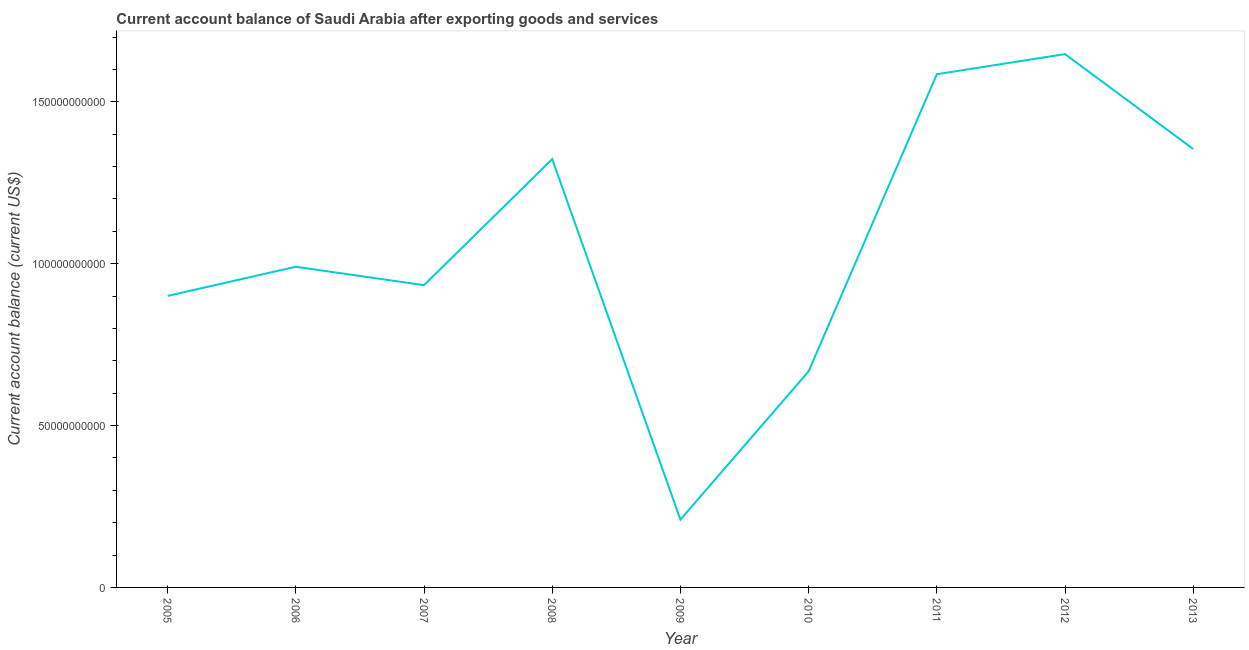What is the current account balance in 2006?
Your answer should be compact. 9.91e+1. Across all years, what is the maximum current account balance?
Offer a terse response. 1.65e+11. Across all years, what is the minimum current account balance?
Give a very brief answer. 2.10e+1. In which year was the current account balance maximum?
Keep it short and to the point. 2012. In which year was the current account balance minimum?
Keep it short and to the point. 2009. What is the sum of the current account balance?
Your answer should be compact. 9.61e+11. What is the difference between the current account balance in 2005 and 2010?
Your answer should be compact. 2.33e+1. What is the average current account balance per year?
Your response must be concise. 1.07e+11. What is the median current account balance?
Keep it short and to the point. 9.91e+1. Do a majority of the years between 2011 and 2012 (inclusive) have current account balance greater than 40000000000 US$?
Make the answer very short. Yes. What is the ratio of the current account balance in 2007 to that in 2011?
Ensure brevity in your answer.  0.59. Is the difference between the current account balance in 2007 and 2008 greater than the difference between any two years?
Offer a very short reply. No. What is the difference between the highest and the second highest current account balance?
Give a very brief answer. 6.22e+09. What is the difference between the highest and the lowest current account balance?
Offer a terse response. 1.44e+11. In how many years, is the current account balance greater than the average current account balance taken over all years?
Offer a very short reply. 4. Does the current account balance monotonically increase over the years?
Offer a terse response. No. Are the values on the major ticks of Y-axis written in scientific E-notation?
Keep it short and to the point. No. Does the graph contain any zero values?
Offer a terse response. No. What is the title of the graph?
Provide a short and direct response. Current account balance of Saudi Arabia after exporting goods and services. What is the label or title of the Y-axis?
Ensure brevity in your answer.  Current account balance (current US$). What is the Current account balance (current US$) of 2005?
Your answer should be compact. 9.01e+1. What is the Current account balance (current US$) of 2006?
Provide a short and direct response. 9.91e+1. What is the Current account balance (current US$) in 2007?
Your answer should be compact. 9.34e+1. What is the Current account balance (current US$) of 2008?
Offer a terse response. 1.32e+11. What is the Current account balance (current US$) of 2009?
Keep it short and to the point. 2.10e+1. What is the Current account balance (current US$) in 2010?
Your answer should be very brief. 6.68e+1. What is the Current account balance (current US$) in 2011?
Provide a short and direct response. 1.59e+11. What is the Current account balance (current US$) of 2012?
Your answer should be very brief. 1.65e+11. What is the Current account balance (current US$) in 2013?
Offer a terse response. 1.35e+11. What is the difference between the Current account balance (current US$) in 2005 and 2006?
Offer a very short reply. -9.01e+09. What is the difference between the Current account balance (current US$) in 2005 and 2007?
Offer a very short reply. -3.32e+09. What is the difference between the Current account balance (current US$) in 2005 and 2008?
Make the answer very short. -4.23e+1. What is the difference between the Current account balance (current US$) in 2005 and 2009?
Your answer should be compact. 6.91e+1. What is the difference between the Current account balance (current US$) in 2005 and 2010?
Provide a short and direct response. 2.33e+1. What is the difference between the Current account balance (current US$) in 2005 and 2011?
Keep it short and to the point. -6.85e+1. What is the difference between the Current account balance (current US$) in 2005 and 2012?
Your answer should be very brief. -7.47e+1. What is the difference between the Current account balance (current US$) in 2005 and 2013?
Give a very brief answer. -4.54e+1. What is the difference between the Current account balance (current US$) in 2006 and 2007?
Your response must be concise. 5.69e+09. What is the difference between the Current account balance (current US$) in 2006 and 2008?
Provide a succinct answer. -3.33e+1. What is the difference between the Current account balance (current US$) in 2006 and 2009?
Your answer should be compact. 7.81e+1. What is the difference between the Current account balance (current US$) in 2006 and 2010?
Your answer should be compact. 3.23e+1. What is the difference between the Current account balance (current US$) in 2006 and 2011?
Keep it short and to the point. -5.95e+1. What is the difference between the Current account balance (current US$) in 2006 and 2012?
Provide a short and direct response. -6.57e+1. What is the difference between the Current account balance (current US$) in 2006 and 2013?
Give a very brief answer. -3.64e+1. What is the difference between the Current account balance (current US$) in 2007 and 2008?
Keep it short and to the point. -3.89e+1. What is the difference between the Current account balance (current US$) in 2007 and 2009?
Ensure brevity in your answer.  7.24e+1. What is the difference between the Current account balance (current US$) in 2007 and 2010?
Give a very brief answer. 2.66e+1. What is the difference between the Current account balance (current US$) in 2007 and 2011?
Your answer should be compact. -6.52e+1. What is the difference between the Current account balance (current US$) in 2007 and 2012?
Your answer should be very brief. -7.14e+1. What is the difference between the Current account balance (current US$) in 2007 and 2013?
Ensure brevity in your answer.  -4.21e+1. What is the difference between the Current account balance (current US$) in 2008 and 2009?
Your answer should be very brief. 1.11e+11. What is the difference between the Current account balance (current US$) in 2008 and 2010?
Your answer should be very brief. 6.56e+1. What is the difference between the Current account balance (current US$) in 2008 and 2011?
Offer a terse response. -2.62e+1. What is the difference between the Current account balance (current US$) in 2008 and 2012?
Ensure brevity in your answer.  -3.24e+1. What is the difference between the Current account balance (current US$) in 2008 and 2013?
Provide a succinct answer. -3.12e+09. What is the difference between the Current account balance (current US$) in 2009 and 2010?
Make the answer very short. -4.58e+1. What is the difference between the Current account balance (current US$) in 2009 and 2011?
Provide a short and direct response. -1.38e+11. What is the difference between the Current account balance (current US$) in 2009 and 2012?
Your response must be concise. -1.44e+11. What is the difference between the Current account balance (current US$) in 2009 and 2013?
Provide a short and direct response. -1.14e+11. What is the difference between the Current account balance (current US$) in 2010 and 2011?
Make the answer very short. -9.18e+1. What is the difference between the Current account balance (current US$) in 2010 and 2012?
Provide a succinct answer. -9.80e+1. What is the difference between the Current account balance (current US$) in 2010 and 2013?
Your answer should be very brief. -6.87e+1. What is the difference between the Current account balance (current US$) in 2011 and 2012?
Your answer should be very brief. -6.22e+09. What is the difference between the Current account balance (current US$) in 2011 and 2013?
Give a very brief answer. 2.31e+1. What is the difference between the Current account balance (current US$) in 2012 and 2013?
Keep it short and to the point. 2.93e+1. What is the ratio of the Current account balance (current US$) in 2005 to that in 2006?
Your response must be concise. 0.91. What is the ratio of the Current account balance (current US$) in 2005 to that in 2008?
Offer a terse response. 0.68. What is the ratio of the Current account balance (current US$) in 2005 to that in 2009?
Offer a terse response. 4.3. What is the ratio of the Current account balance (current US$) in 2005 to that in 2010?
Provide a succinct answer. 1.35. What is the ratio of the Current account balance (current US$) in 2005 to that in 2011?
Provide a succinct answer. 0.57. What is the ratio of the Current account balance (current US$) in 2005 to that in 2012?
Provide a succinct answer. 0.55. What is the ratio of the Current account balance (current US$) in 2005 to that in 2013?
Ensure brevity in your answer.  0.67. What is the ratio of the Current account balance (current US$) in 2006 to that in 2007?
Keep it short and to the point. 1.06. What is the ratio of the Current account balance (current US$) in 2006 to that in 2008?
Offer a very short reply. 0.75. What is the ratio of the Current account balance (current US$) in 2006 to that in 2009?
Provide a succinct answer. 4.73. What is the ratio of the Current account balance (current US$) in 2006 to that in 2010?
Your response must be concise. 1.48. What is the ratio of the Current account balance (current US$) in 2006 to that in 2012?
Provide a succinct answer. 0.6. What is the ratio of the Current account balance (current US$) in 2006 to that in 2013?
Your answer should be compact. 0.73. What is the ratio of the Current account balance (current US$) in 2007 to that in 2008?
Keep it short and to the point. 0.71. What is the ratio of the Current account balance (current US$) in 2007 to that in 2009?
Make the answer very short. 4.46. What is the ratio of the Current account balance (current US$) in 2007 to that in 2010?
Provide a succinct answer. 1.4. What is the ratio of the Current account balance (current US$) in 2007 to that in 2011?
Your response must be concise. 0.59. What is the ratio of the Current account balance (current US$) in 2007 to that in 2012?
Offer a very short reply. 0.57. What is the ratio of the Current account balance (current US$) in 2007 to that in 2013?
Your response must be concise. 0.69. What is the ratio of the Current account balance (current US$) in 2008 to that in 2009?
Keep it short and to the point. 6.32. What is the ratio of the Current account balance (current US$) in 2008 to that in 2010?
Offer a very short reply. 1.98. What is the ratio of the Current account balance (current US$) in 2008 to that in 2011?
Ensure brevity in your answer.  0.83. What is the ratio of the Current account balance (current US$) in 2008 to that in 2012?
Provide a succinct answer. 0.8. What is the ratio of the Current account balance (current US$) in 2008 to that in 2013?
Ensure brevity in your answer.  0.98. What is the ratio of the Current account balance (current US$) in 2009 to that in 2010?
Your answer should be very brief. 0.31. What is the ratio of the Current account balance (current US$) in 2009 to that in 2011?
Your answer should be compact. 0.13. What is the ratio of the Current account balance (current US$) in 2009 to that in 2012?
Make the answer very short. 0.13. What is the ratio of the Current account balance (current US$) in 2009 to that in 2013?
Keep it short and to the point. 0.15. What is the ratio of the Current account balance (current US$) in 2010 to that in 2011?
Offer a very short reply. 0.42. What is the ratio of the Current account balance (current US$) in 2010 to that in 2012?
Give a very brief answer. 0.41. What is the ratio of the Current account balance (current US$) in 2010 to that in 2013?
Give a very brief answer. 0.49. What is the ratio of the Current account balance (current US$) in 2011 to that in 2013?
Provide a short and direct response. 1.17. What is the ratio of the Current account balance (current US$) in 2012 to that in 2013?
Your answer should be very brief. 1.22. 